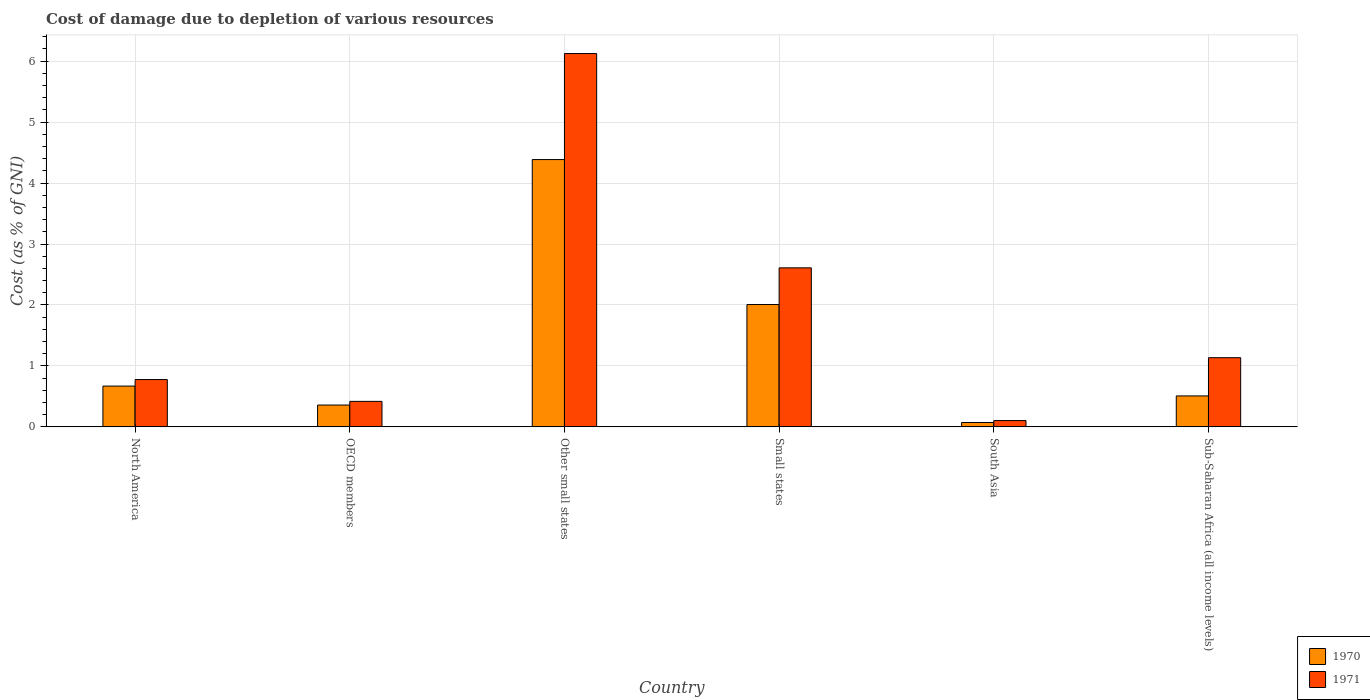How many different coloured bars are there?
Ensure brevity in your answer.  2. How many groups of bars are there?
Provide a short and direct response. 6. Are the number of bars per tick equal to the number of legend labels?
Provide a short and direct response. Yes. Are the number of bars on each tick of the X-axis equal?
Provide a succinct answer. Yes. How many bars are there on the 2nd tick from the left?
Offer a terse response. 2. How many bars are there on the 5th tick from the right?
Provide a short and direct response. 2. What is the label of the 3rd group of bars from the left?
Keep it short and to the point. Other small states. What is the cost of damage caused due to the depletion of various resources in 1970 in South Asia?
Provide a short and direct response. 0.07. Across all countries, what is the maximum cost of damage caused due to the depletion of various resources in 1970?
Your answer should be very brief. 4.39. Across all countries, what is the minimum cost of damage caused due to the depletion of various resources in 1971?
Give a very brief answer. 0.1. In which country was the cost of damage caused due to the depletion of various resources in 1971 maximum?
Keep it short and to the point. Other small states. In which country was the cost of damage caused due to the depletion of various resources in 1970 minimum?
Ensure brevity in your answer.  South Asia. What is the total cost of damage caused due to the depletion of various resources in 1971 in the graph?
Provide a short and direct response. 11.17. What is the difference between the cost of damage caused due to the depletion of various resources in 1970 in Other small states and that in Sub-Saharan Africa (all income levels)?
Offer a terse response. 3.88. What is the difference between the cost of damage caused due to the depletion of various resources in 1971 in OECD members and the cost of damage caused due to the depletion of various resources in 1970 in Sub-Saharan Africa (all income levels)?
Your answer should be very brief. -0.09. What is the average cost of damage caused due to the depletion of various resources in 1971 per country?
Your answer should be very brief. 1.86. What is the difference between the cost of damage caused due to the depletion of various resources of/in 1970 and cost of damage caused due to the depletion of various resources of/in 1971 in Other small states?
Provide a short and direct response. -1.74. What is the ratio of the cost of damage caused due to the depletion of various resources in 1971 in North America to that in Sub-Saharan Africa (all income levels)?
Offer a very short reply. 0.68. What is the difference between the highest and the second highest cost of damage caused due to the depletion of various resources in 1970?
Offer a very short reply. -1.34. What is the difference between the highest and the lowest cost of damage caused due to the depletion of various resources in 1970?
Give a very brief answer. 4.31. Is the sum of the cost of damage caused due to the depletion of various resources in 1971 in OECD members and Small states greater than the maximum cost of damage caused due to the depletion of various resources in 1970 across all countries?
Provide a succinct answer. No. What does the 2nd bar from the left in OECD members represents?
Offer a terse response. 1971. What does the 2nd bar from the right in OECD members represents?
Keep it short and to the point. 1970. Are all the bars in the graph horizontal?
Keep it short and to the point. No. How many countries are there in the graph?
Provide a succinct answer. 6. What is the difference between two consecutive major ticks on the Y-axis?
Ensure brevity in your answer.  1. Does the graph contain any zero values?
Keep it short and to the point. No. What is the title of the graph?
Your answer should be compact. Cost of damage due to depletion of various resources. Does "1979" appear as one of the legend labels in the graph?
Provide a succinct answer. No. What is the label or title of the X-axis?
Make the answer very short. Country. What is the label or title of the Y-axis?
Your answer should be very brief. Cost (as % of GNI). What is the Cost (as % of GNI) in 1970 in North America?
Provide a short and direct response. 0.67. What is the Cost (as % of GNI) of 1971 in North America?
Give a very brief answer. 0.78. What is the Cost (as % of GNI) of 1970 in OECD members?
Ensure brevity in your answer.  0.36. What is the Cost (as % of GNI) in 1971 in OECD members?
Your answer should be compact. 0.42. What is the Cost (as % of GNI) of 1970 in Other small states?
Your response must be concise. 4.39. What is the Cost (as % of GNI) of 1971 in Other small states?
Offer a terse response. 6.13. What is the Cost (as % of GNI) of 1970 in Small states?
Offer a terse response. 2.01. What is the Cost (as % of GNI) in 1971 in Small states?
Keep it short and to the point. 2.61. What is the Cost (as % of GNI) of 1970 in South Asia?
Give a very brief answer. 0.07. What is the Cost (as % of GNI) of 1971 in South Asia?
Provide a short and direct response. 0.1. What is the Cost (as % of GNI) in 1970 in Sub-Saharan Africa (all income levels)?
Your answer should be compact. 0.51. What is the Cost (as % of GNI) in 1971 in Sub-Saharan Africa (all income levels)?
Your response must be concise. 1.13. Across all countries, what is the maximum Cost (as % of GNI) in 1970?
Your answer should be compact. 4.39. Across all countries, what is the maximum Cost (as % of GNI) in 1971?
Your response must be concise. 6.13. Across all countries, what is the minimum Cost (as % of GNI) in 1970?
Give a very brief answer. 0.07. Across all countries, what is the minimum Cost (as % of GNI) in 1971?
Your answer should be compact. 0.1. What is the total Cost (as % of GNI) of 1971 in the graph?
Your answer should be very brief. 11.17. What is the difference between the Cost (as % of GNI) of 1970 in North America and that in OECD members?
Your answer should be very brief. 0.31. What is the difference between the Cost (as % of GNI) in 1971 in North America and that in OECD members?
Ensure brevity in your answer.  0.36. What is the difference between the Cost (as % of GNI) of 1970 in North America and that in Other small states?
Provide a short and direct response. -3.72. What is the difference between the Cost (as % of GNI) of 1971 in North America and that in Other small states?
Offer a terse response. -5.35. What is the difference between the Cost (as % of GNI) in 1970 in North America and that in Small states?
Offer a very short reply. -1.34. What is the difference between the Cost (as % of GNI) in 1971 in North America and that in Small states?
Ensure brevity in your answer.  -1.83. What is the difference between the Cost (as % of GNI) of 1970 in North America and that in South Asia?
Offer a terse response. 0.6. What is the difference between the Cost (as % of GNI) in 1971 in North America and that in South Asia?
Your answer should be very brief. 0.67. What is the difference between the Cost (as % of GNI) in 1970 in North America and that in Sub-Saharan Africa (all income levels)?
Ensure brevity in your answer.  0.16. What is the difference between the Cost (as % of GNI) in 1971 in North America and that in Sub-Saharan Africa (all income levels)?
Make the answer very short. -0.36. What is the difference between the Cost (as % of GNI) of 1970 in OECD members and that in Other small states?
Provide a succinct answer. -4.03. What is the difference between the Cost (as % of GNI) in 1971 in OECD members and that in Other small states?
Provide a short and direct response. -5.71. What is the difference between the Cost (as % of GNI) of 1970 in OECD members and that in Small states?
Ensure brevity in your answer.  -1.65. What is the difference between the Cost (as % of GNI) of 1971 in OECD members and that in Small states?
Provide a succinct answer. -2.19. What is the difference between the Cost (as % of GNI) of 1970 in OECD members and that in South Asia?
Your answer should be compact. 0.29. What is the difference between the Cost (as % of GNI) in 1971 in OECD members and that in South Asia?
Your answer should be compact. 0.31. What is the difference between the Cost (as % of GNI) of 1970 in OECD members and that in Sub-Saharan Africa (all income levels)?
Provide a succinct answer. -0.15. What is the difference between the Cost (as % of GNI) in 1971 in OECD members and that in Sub-Saharan Africa (all income levels)?
Provide a succinct answer. -0.72. What is the difference between the Cost (as % of GNI) of 1970 in Other small states and that in Small states?
Keep it short and to the point. 2.38. What is the difference between the Cost (as % of GNI) in 1971 in Other small states and that in Small states?
Your answer should be compact. 3.52. What is the difference between the Cost (as % of GNI) of 1970 in Other small states and that in South Asia?
Keep it short and to the point. 4.31. What is the difference between the Cost (as % of GNI) of 1971 in Other small states and that in South Asia?
Keep it short and to the point. 6.02. What is the difference between the Cost (as % of GNI) in 1970 in Other small states and that in Sub-Saharan Africa (all income levels)?
Ensure brevity in your answer.  3.88. What is the difference between the Cost (as % of GNI) of 1971 in Other small states and that in Sub-Saharan Africa (all income levels)?
Your answer should be very brief. 4.99. What is the difference between the Cost (as % of GNI) in 1970 in Small states and that in South Asia?
Offer a terse response. 1.94. What is the difference between the Cost (as % of GNI) of 1971 in Small states and that in South Asia?
Offer a terse response. 2.51. What is the difference between the Cost (as % of GNI) in 1970 in Small states and that in Sub-Saharan Africa (all income levels)?
Your answer should be compact. 1.5. What is the difference between the Cost (as % of GNI) of 1971 in Small states and that in Sub-Saharan Africa (all income levels)?
Your answer should be compact. 1.47. What is the difference between the Cost (as % of GNI) of 1970 in South Asia and that in Sub-Saharan Africa (all income levels)?
Keep it short and to the point. -0.44. What is the difference between the Cost (as % of GNI) of 1971 in South Asia and that in Sub-Saharan Africa (all income levels)?
Make the answer very short. -1.03. What is the difference between the Cost (as % of GNI) in 1970 in North America and the Cost (as % of GNI) in 1971 in OECD members?
Keep it short and to the point. 0.25. What is the difference between the Cost (as % of GNI) of 1970 in North America and the Cost (as % of GNI) of 1971 in Other small states?
Your answer should be very brief. -5.46. What is the difference between the Cost (as % of GNI) of 1970 in North America and the Cost (as % of GNI) of 1971 in Small states?
Offer a very short reply. -1.94. What is the difference between the Cost (as % of GNI) of 1970 in North America and the Cost (as % of GNI) of 1971 in South Asia?
Offer a very short reply. 0.57. What is the difference between the Cost (as % of GNI) in 1970 in North America and the Cost (as % of GNI) in 1971 in Sub-Saharan Africa (all income levels)?
Keep it short and to the point. -0.47. What is the difference between the Cost (as % of GNI) of 1970 in OECD members and the Cost (as % of GNI) of 1971 in Other small states?
Offer a terse response. -5.77. What is the difference between the Cost (as % of GNI) of 1970 in OECD members and the Cost (as % of GNI) of 1971 in Small states?
Your answer should be compact. -2.25. What is the difference between the Cost (as % of GNI) of 1970 in OECD members and the Cost (as % of GNI) of 1971 in South Asia?
Make the answer very short. 0.25. What is the difference between the Cost (as % of GNI) of 1970 in OECD members and the Cost (as % of GNI) of 1971 in Sub-Saharan Africa (all income levels)?
Your answer should be compact. -0.78. What is the difference between the Cost (as % of GNI) in 1970 in Other small states and the Cost (as % of GNI) in 1971 in Small states?
Offer a very short reply. 1.78. What is the difference between the Cost (as % of GNI) in 1970 in Other small states and the Cost (as % of GNI) in 1971 in South Asia?
Provide a succinct answer. 4.28. What is the difference between the Cost (as % of GNI) of 1970 in Other small states and the Cost (as % of GNI) of 1971 in Sub-Saharan Africa (all income levels)?
Offer a very short reply. 3.25. What is the difference between the Cost (as % of GNI) in 1970 in Small states and the Cost (as % of GNI) in 1971 in South Asia?
Ensure brevity in your answer.  1.9. What is the difference between the Cost (as % of GNI) of 1970 in Small states and the Cost (as % of GNI) of 1971 in Sub-Saharan Africa (all income levels)?
Your answer should be compact. 0.87. What is the difference between the Cost (as % of GNI) of 1970 in South Asia and the Cost (as % of GNI) of 1971 in Sub-Saharan Africa (all income levels)?
Make the answer very short. -1.06. What is the average Cost (as % of GNI) of 1971 per country?
Your answer should be very brief. 1.86. What is the difference between the Cost (as % of GNI) in 1970 and Cost (as % of GNI) in 1971 in North America?
Your response must be concise. -0.11. What is the difference between the Cost (as % of GNI) in 1970 and Cost (as % of GNI) in 1971 in OECD members?
Your answer should be very brief. -0.06. What is the difference between the Cost (as % of GNI) in 1970 and Cost (as % of GNI) in 1971 in Other small states?
Make the answer very short. -1.74. What is the difference between the Cost (as % of GNI) of 1970 and Cost (as % of GNI) of 1971 in Small states?
Provide a short and direct response. -0.6. What is the difference between the Cost (as % of GNI) of 1970 and Cost (as % of GNI) of 1971 in South Asia?
Your answer should be very brief. -0.03. What is the difference between the Cost (as % of GNI) in 1970 and Cost (as % of GNI) in 1971 in Sub-Saharan Africa (all income levels)?
Ensure brevity in your answer.  -0.63. What is the ratio of the Cost (as % of GNI) in 1970 in North America to that in OECD members?
Your answer should be compact. 1.87. What is the ratio of the Cost (as % of GNI) of 1971 in North America to that in OECD members?
Make the answer very short. 1.85. What is the ratio of the Cost (as % of GNI) of 1970 in North America to that in Other small states?
Your answer should be compact. 0.15. What is the ratio of the Cost (as % of GNI) in 1971 in North America to that in Other small states?
Provide a short and direct response. 0.13. What is the ratio of the Cost (as % of GNI) of 1970 in North America to that in Small states?
Ensure brevity in your answer.  0.33. What is the ratio of the Cost (as % of GNI) in 1971 in North America to that in Small states?
Give a very brief answer. 0.3. What is the ratio of the Cost (as % of GNI) of 1970 in North America to that in South Asia?
Give a very brief answer. 9.34. What is the ratio of the Cost (as % of GNI) of 1971 in North America to that in South Asia?
Your response must be concise. 7.49. What is the ratio of the Cost (as % of GNI) of 1970 in North America to that in Sub-Saharan Africa (all income levels)?
Ensure brevity in your answer.  1.32. What is the ratio of the Cost (as % of GNI) of 1971 in North America to that in Sub-Saharan Africa (all income levels)?
Keep it short and to the point. 0.68. What is the ratio of the Cost (as % of GNI) in 1970 in OECD members to that in Other small states?
Keep it short and to the point. 0.08. What is the ratio of the Cost (as % of GNI) in 1971 in OECD members to that in Other small states?
Offer a very short reply. 0.07. What is the ratio of the Cost (as % of GNI) of 1970 in OECD members to that in Small states?
Keep it short and to the point. 0.18. What is the ratio of the Cost (as % of GNI) of 1971 in OECD members to that in Small states?
Provide a short and direct response. 0.16. What is the ratio of the Cost (as % of GNI) in 1970 in OECD members to that in South Asia?
Offer a very short reply. 5. What is the ratio of the Cost (as % of GNI) of 1971 in OECD members to that in South Asia?
Keep it short and to the point. 4.04. What is the ratio of the Cost (as % of GNI) of 1970 in OECD members to that in Sub-Saharan Africa (all income levels)?
Make the answer very short. 0.7. What is the ratio of the Cost (as % of GNI) in 1971 in OECD members to that in Sub-Saharan Africa (all income levels)?
Your answer should be compact. 0.37. What is the ratio of the Cost (as % of GNI) of 1970 in Other small states to that in Small states?
Make the answer very short. 2.18. What is the ratio of the Cost (as % of GNI) in 1971 in Other small states to that in Small states?
Offer a terse response. 2.35. What is the ratio of the Cost (as % of GNI) in 1970 in Other small states to that in South Asia?
Your answer should be very brief. 61.21. What is the ratio of the Cost (as % of GNI) of 1971 in Other small states to that in South Asia?
Provide a succinct answer. 59.08. What is the ratio of the Cost (as % of GNI) in 1970 in Other small states to that in Sub-Saharan Africa (all income levels)?
Keep it short and to the point. 8.63. What is the ratio of the Cost (as % of GNI) of 1971 in Other small states to that in Sub-Saharan Africa (all income levels)?
Ensure brevity in your answer.  5.4. What is the ratio of the Cost (as % of GNI) of 1970 in Small states to that in South Asia?
Provide a succinct answer. 28.02. What is the ratio of the Cost (as % of GNI) in 1971 in Small states to that in South Asia?
Ensure brevity in your answer.  25.17. What is the ratio of the Cost (as % of GNI) in 1970 in Small states to that in Sub-Saharan Africa (all income levels)?
Offer a terse response. 3.95. What is the ratio of the Cost (as % of GNI) in 1971 in Small states to that in Sub-Saharan Africa (all income levels)?
Your answer should be very brief. 2.3. What is the ratio of the Cost (as % of GNI) in 1970 in South Asia to that in Sub-Saharan Africa (all income levels)?
Your answer should be very brief. 0.14. What is the ratio of the Cost (as % of GNI) of 1971 in South Asia to that in Sub-Saharan Africa (all income levels)?
Offer a terse response. 0.09. What is the difference between the highest and the second highest Cost (as % of GNI) of 1970?
Ensure brevity in your answer.  2.38. What is the difference between the highest and the second highest Cost (as % of GNI) in 1971?
Your response must be concise. 3.52. What is the difference between the highest and the lowest Cost (as % of GNI) of 1970?
Offer a very short reply. 4.31. What is the difference between the highest and the lowest Cost (as % of GNI) in 1971?
Your answer should be compact. 6.02. 